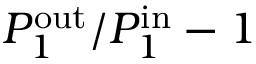<formula> <loc_0><loc_0><loc_500><loc_500>P _ { 1 } ^ { o u t } / P _ { 1 } ^ { i n } - 1</formula> 